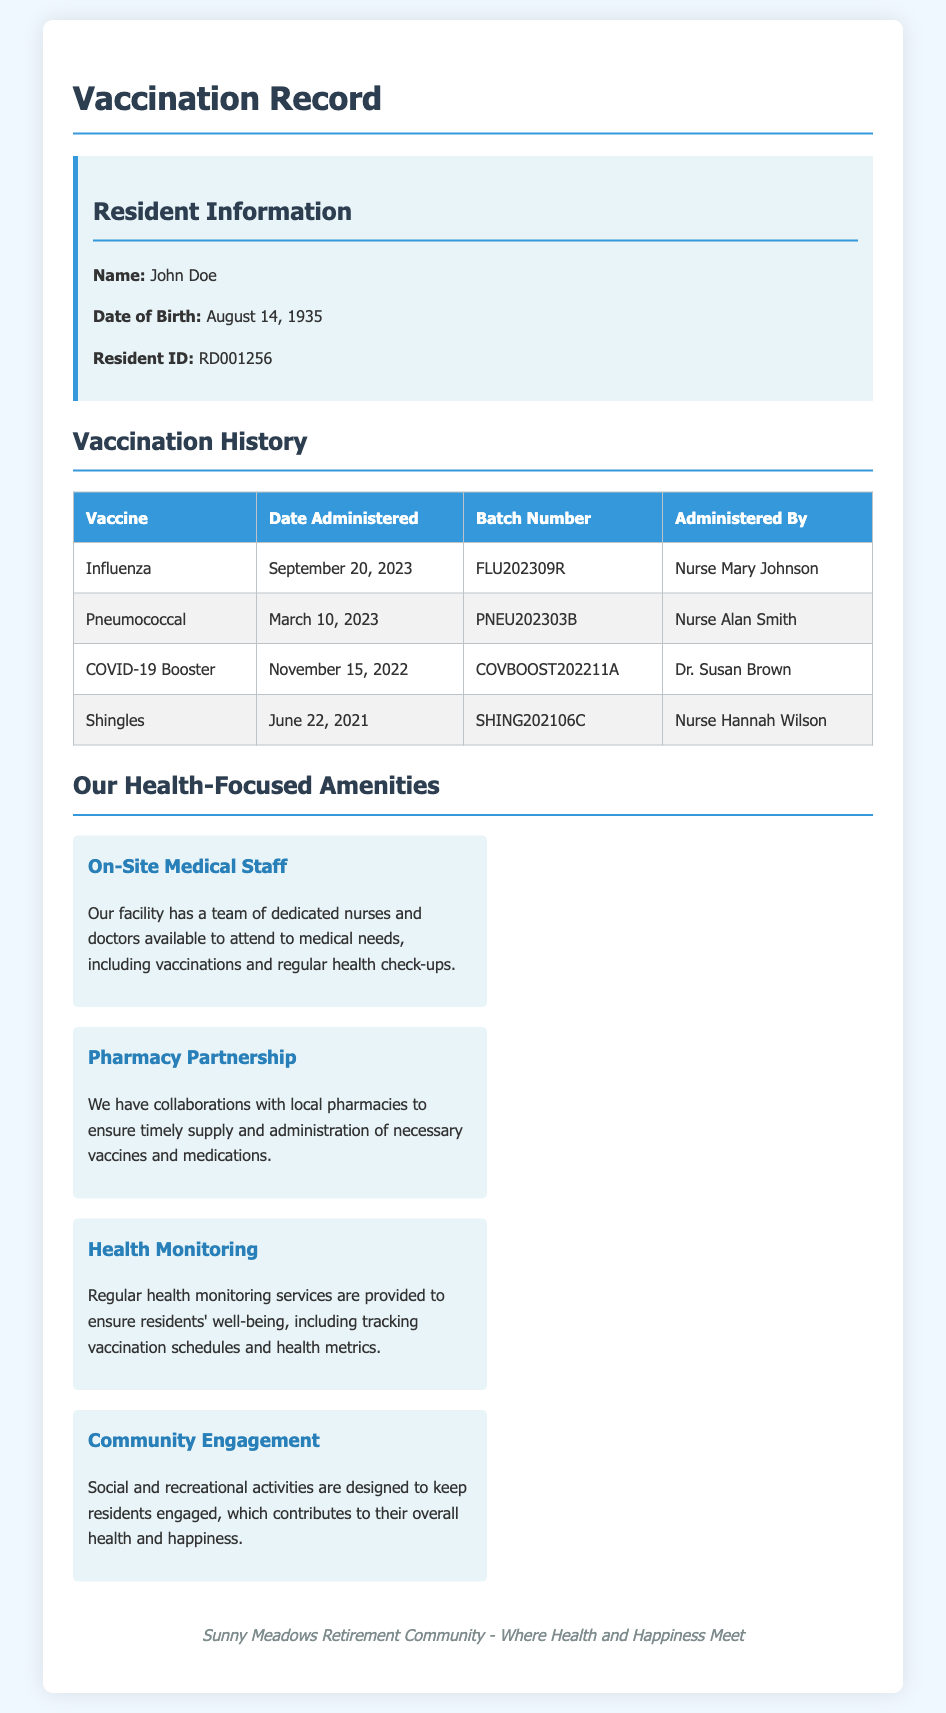What is the name of the resident? The name of the resident is listed at the top of the resident information section in the document.
Answer: John Doe When was the influenza vaccine administered? The date for the influenza vaccine is specified in the vaccination history table.
Answer: September 20, 2023 Who administered the pneumococcal vaccine? The document includes the name of the personnel who administered each vaccine in the vaccination history table.
Answer: Nurse Alan Smith What is the batch number for the COVID-19 booster? The batch number is indicated in the vaccination history table corresponding to the COVID-19 booster shot.
Answer: COVBOOST202211A How many different vaccines are listed in the record? The document provides a count of the unique vaccines in the vaccination history section.
Answer: Four What role does Nurse Mary Johnson hold? The document indicates her as the person who administered the influenza vaccine.
Answer: Nurse Which amenity focuses on health monitoring? The health-related amenities section describes different features, one of which emphasizes health monitoring services.
Answer: Health Monitoring What is the date of the shingles vaccine administration? The date for the shingles vaccine is detailed in the vaccination history table.
Answer: June 22, 2021 Which medical personnel collaborated for the vaccinations? The document mentions specific medical staff responsible for the vaccinations administered to residents.
Answer: Nurse and Doctor 